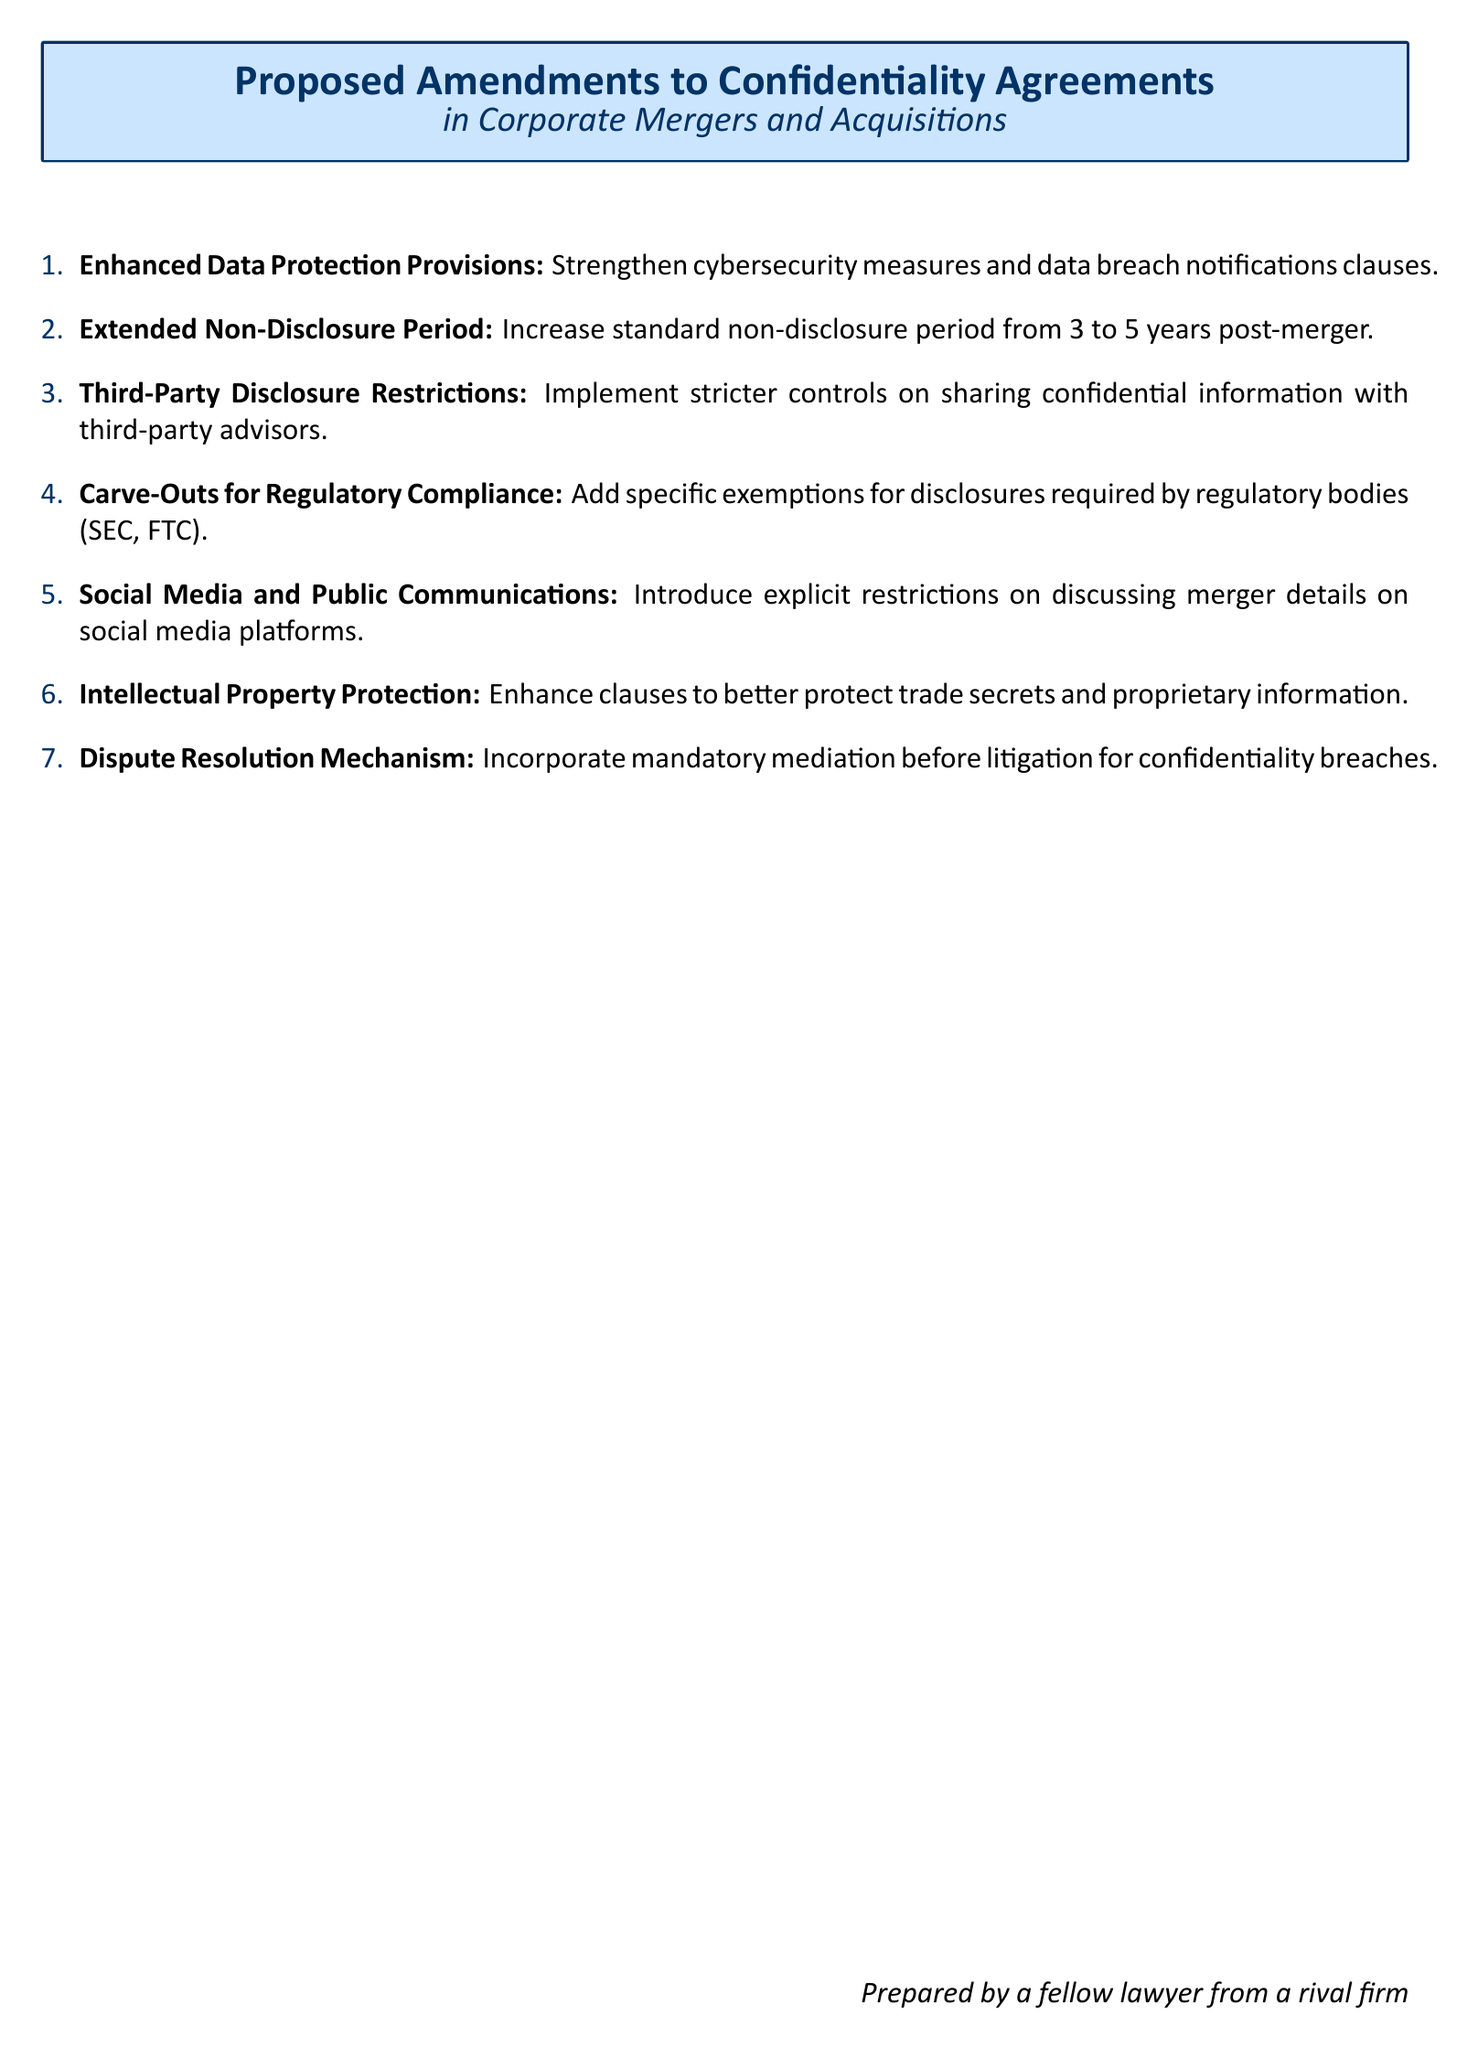What are the proposed amendments to confidentiality agreements? The document lists seven specific proposed amendments related to confidentiality agreements in corporate mergers and acquisitions.
Answer: Seven What is the current standard non-disclosure period? The document states that the current standard non-disclosure period is increased from 3 to 5 years post-merger.
Answer: 3 years What is the extended non-disclosure period proposed? The document indicates an increase in the non-disclosure period from 3 to 5 years.
Answer: 5 years What specific exemptions are included in the proposed amendments? The proposed amendments include carve-outs for disclosures required by regulatory bodies like SEC and FTC.
Answer: Regulatory bodies What does the proposed amendment on third-party disclosure entail? The document proposes implementing stricter controls on sharing confidential information with third-party advisors.
Answer: Stricter controls What dispute resolution mechanism is proposed for confidentiality breaches? The document incorporates mandatory mediation before litigation as a mechanism for confidentiality breaches.
Answer: Mandatory mediation What social media restrictions are proposed? The document introduces explicit restrictions on discussing merger details on social media platforms.
Answer: Explicit restrictions What enhancement is suggested for intellectual property protection? The document suggests enhancing clauses to better protect trade secrets and proprietary information.
Answer: Enhance clauses 